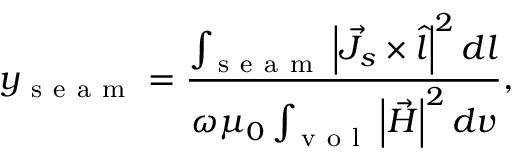<formula> <loc_0><loc_0><loc_500><loc_500>y _ { s e a m } = \frac { \int _ { s e a m } \left | \vec { J } _ { s } \times \hat { l } \right | ^ { 2 } d l } { \omega \mu _ { 0 } \int _ { v o l } \left | \vec { H } \right | ^ { 2 } d v } ,</formula> 